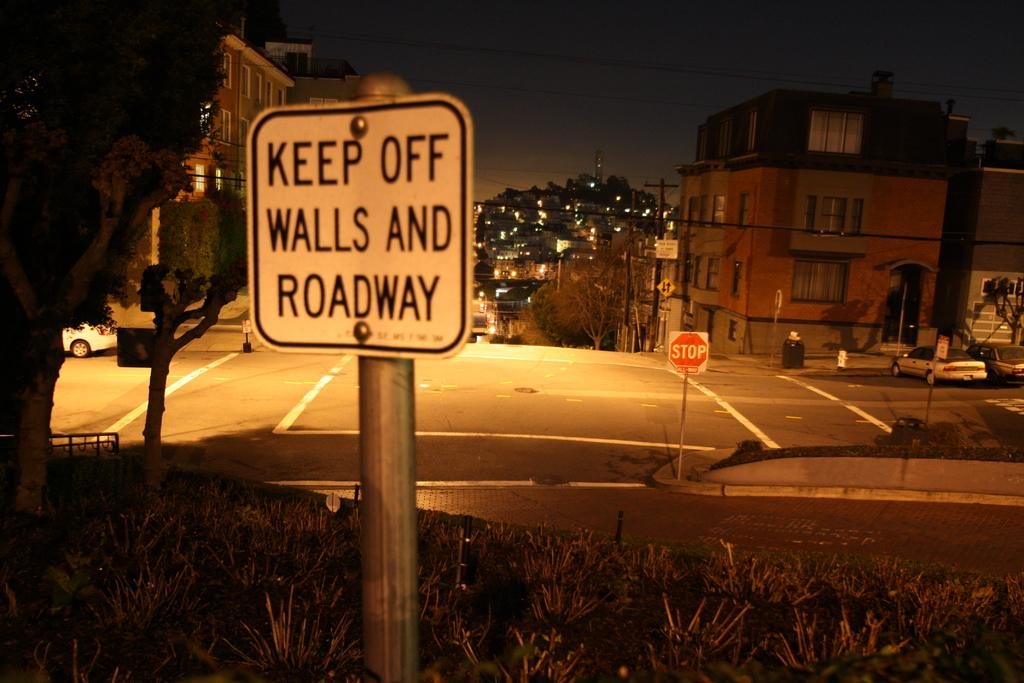<image>
Summarize the visual content of the image. A sign at an intersection warning to keep hands off of the walls and roadway. 